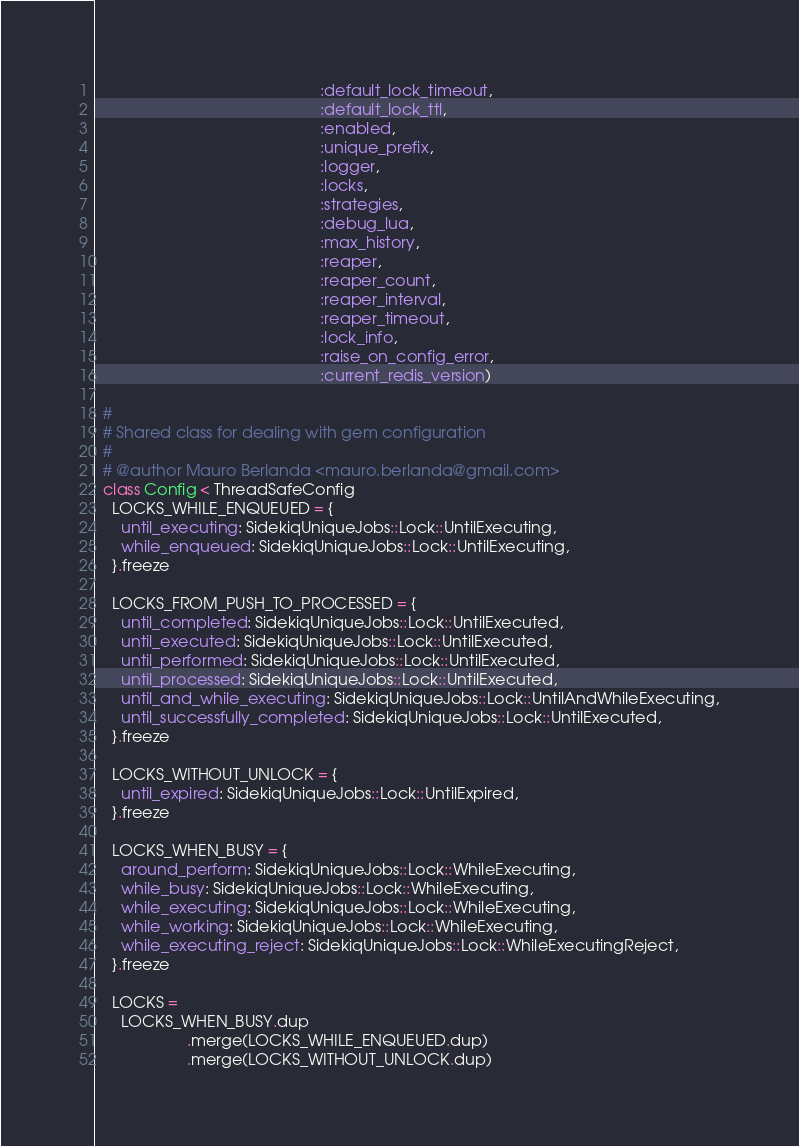Convert code to text. <code><loc_0><loc_0><loc_500><loc_500><_Ruby_>                                                   :default_lock_timeout,
                                                   :default_lock_ttl,
                                                   :enabled,
                                                   :unique_prefix,
                                                   :logger,
                                                   :locks,
                                                   :strategies,
                                                   :debug_lua,
                                                   :max_history,
                                                   :reaper,
                                                   :reaper_count,
                                                   :reaper_interval,
                                                   :reaper_timeout,
                                                   :lock_info,
                                                   :raise_on_config_error,
                                                   :current_redis_version)

  #
  # Shared class for dealing with gem configuration
  #
  # @author Mauro Berlanda <mauro.berlanda@gmail.com>
  class Config < ThreadSafeConfig
    LOCKS_WHILE_ENQUEUED = {
      until_executing: SidekiqUniqueJobs::Lock::UntilExecuting,
      while_enqueued: SidekiqUniqueJobs::Lock::UntilExecuting,
    }.freeze

    LOCKS_FROM_PUSH_TO_PROCESSED = {
      until_completed: SidekiqUniqueJobs::Lock::UntilExecuted,
      until_executed: SidekiqUniqueJobs::Lock::UntilExecuted,
      until_performed: SidekiqUniqueJobs::Lock::UntilExecuted,
      until_processed: SidekiqUniqueJobs::Lock::UntilExecuted,
      until_and_while_executing: SidekiqUniqueJobs::Lock::UntilAndWhileExecuting,
      until_successfully_completed: SidekiqUniqueJobs::Lock::UntilExecuted,
    }.freeze

    LOCKS_WITHOUT_UNLOCK = {
      until_expired: SidekiqUniqueJobs::Lock::UntilExpired,
    }.freeze

    LOCKS_WHEN_BUSY = {
      around_perform: SidekiqUniqueJobs::Lock::WhileExecuting,
      while_busy: SidekiqUniqueJobs::Lock::WhileExecuting,
      while_executing: SidekiqUniqueJobs::Lock::WhileExecuting,
      while_working: SidekiqUniqueJobs::Lock::WhileExecuting,
      while_executing_reject: SidekiqUniqueJobs::Lock::WhileExecutingReject,
    }.freeze

    LOCKS =
      LOCKS_WHEN_BUSY.dup
                     .merge(LOCKS_WHILE_ENQUEUED.dup)
                     .merge(LOCKS_WITHOUT_UNLOCK.dup)</code> 